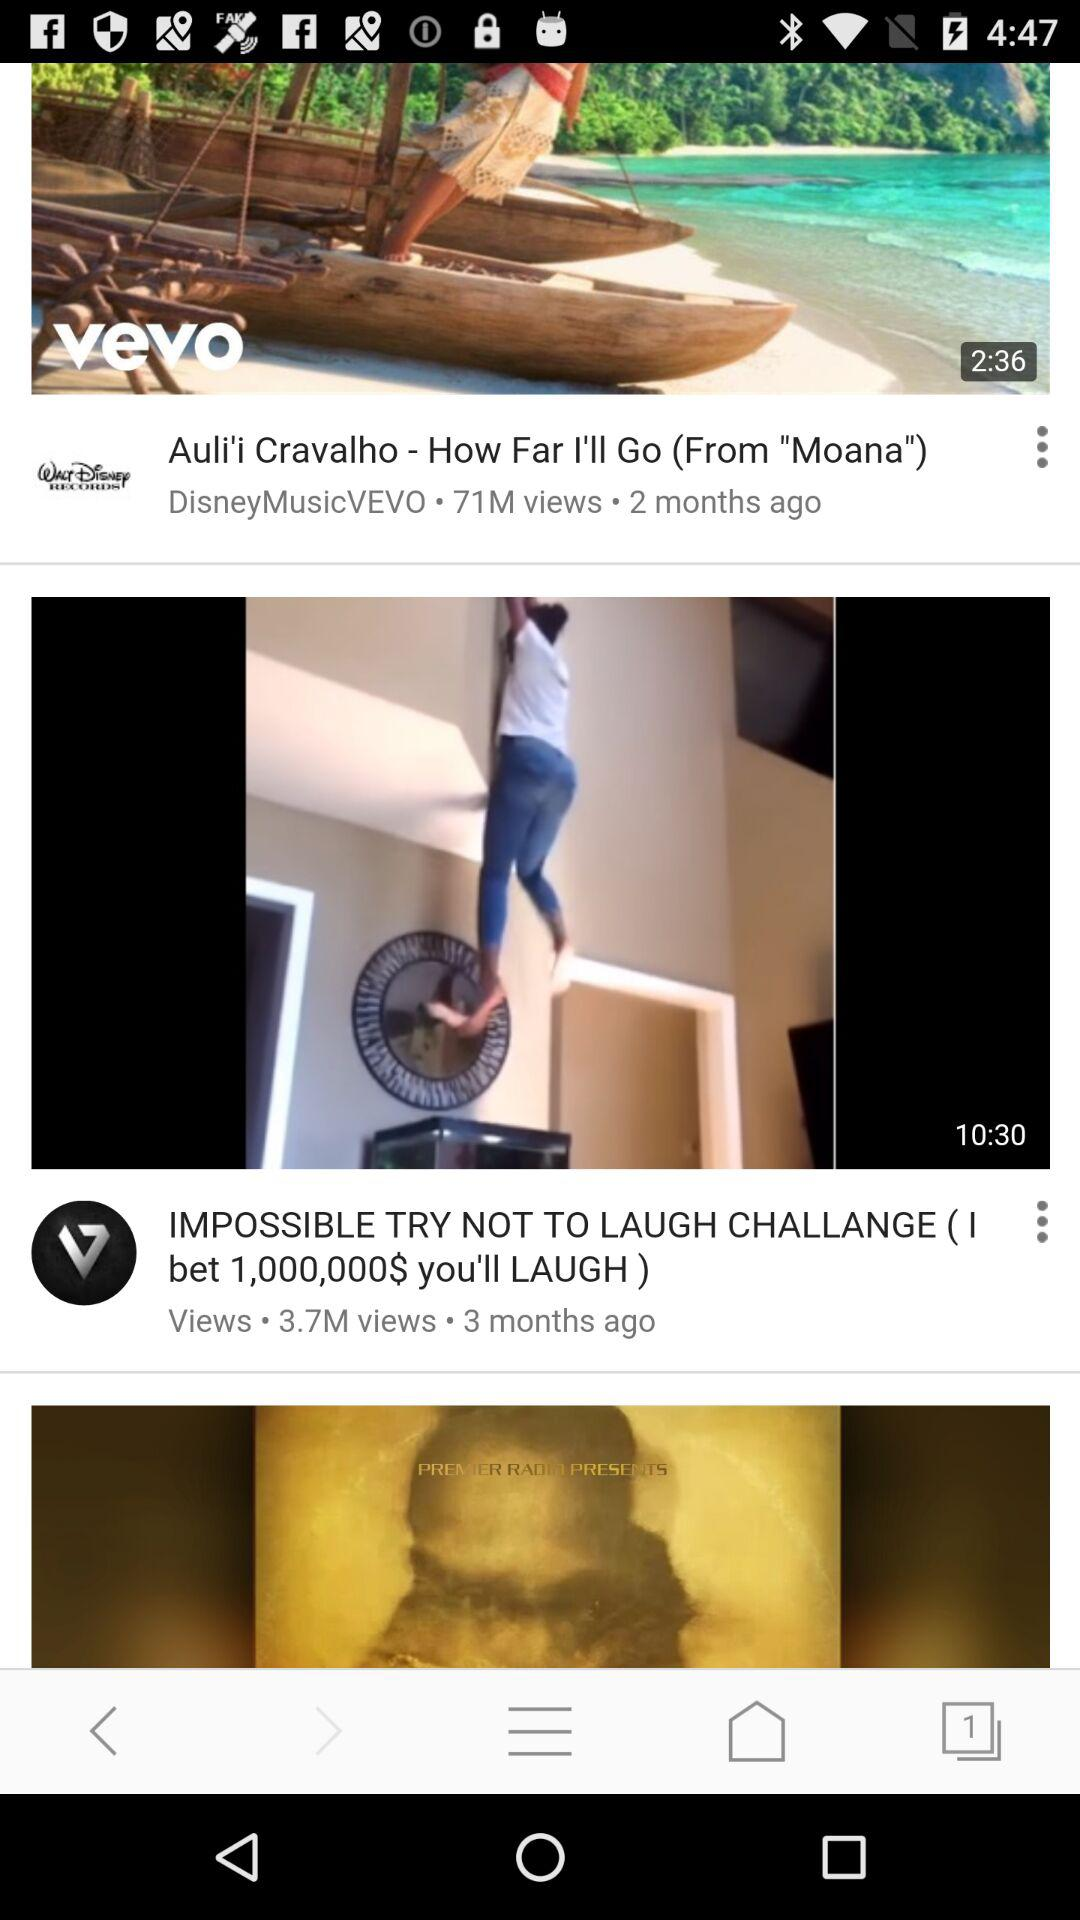When was "How Far I'll Go" posted? "How Far I'll Go" was posted two months ago. 